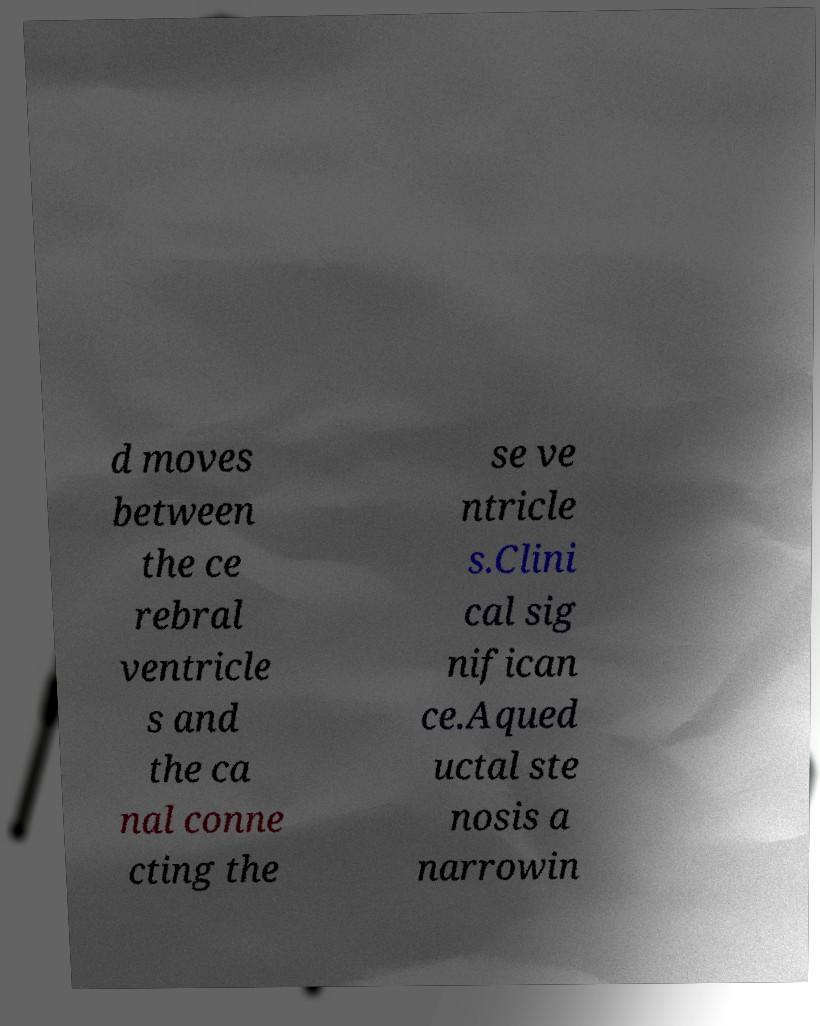For documentation purposes, I need the text within this image transcribed. Could you provide that? d moves between the ce rebral ventricle s and the ca nal conne cting the se ve ntricle s.Clini cal sig nifican ce.Aqued uctal ste nosis a narrowin 